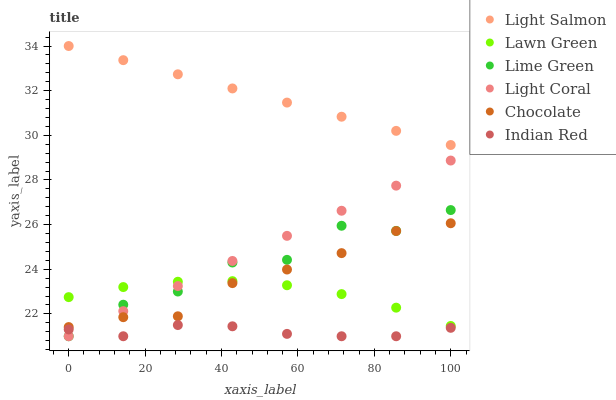Does Indian Red have the minimum area under the curve?
Answer yes or no. Yes. Does Light Salmon have the maximum area under the curve?
Answer yes or no. Yes. Does Chocolate have the minimum area under the curve?
Answer yes or no. No. Does Chocolate have the maximum area under the curve?
Answer yes or no. No. Is Light Coral the smoothest?
Answer yes or no. Yes. Is Lime Green the roughest?
Answer yes or no. Yes. Is Light Salmon the smoothest?
Answer yes or no. No. Is Light Salmon the roughest?
Answer yes or no. No. Does Light Coral have the lowest value?
Answer yes or no. Yes. Does Chocolate have the lowest value?
Answer yes or no. No. Does Light Salmon have the highest value?
Answer yes or no. Yes. Does Chocolate have the highest value?
Answer yes or no. No. Is Chocolate less than Light Salmon?
Answer yes or no. Yes. Is Lawn Green greater than Indian Red?
Answer yes or no. Yes. Does Lime Green intersect Chocolate?
Answer yes or no. Yes. Is Lime Green less than Chocolate?
Answer yes or no. No. Is Lime Green greater than Chocolate?
Answer yes or no. No. Does Chocolate intersect Light Salmon?
Answer yes or no. No. 